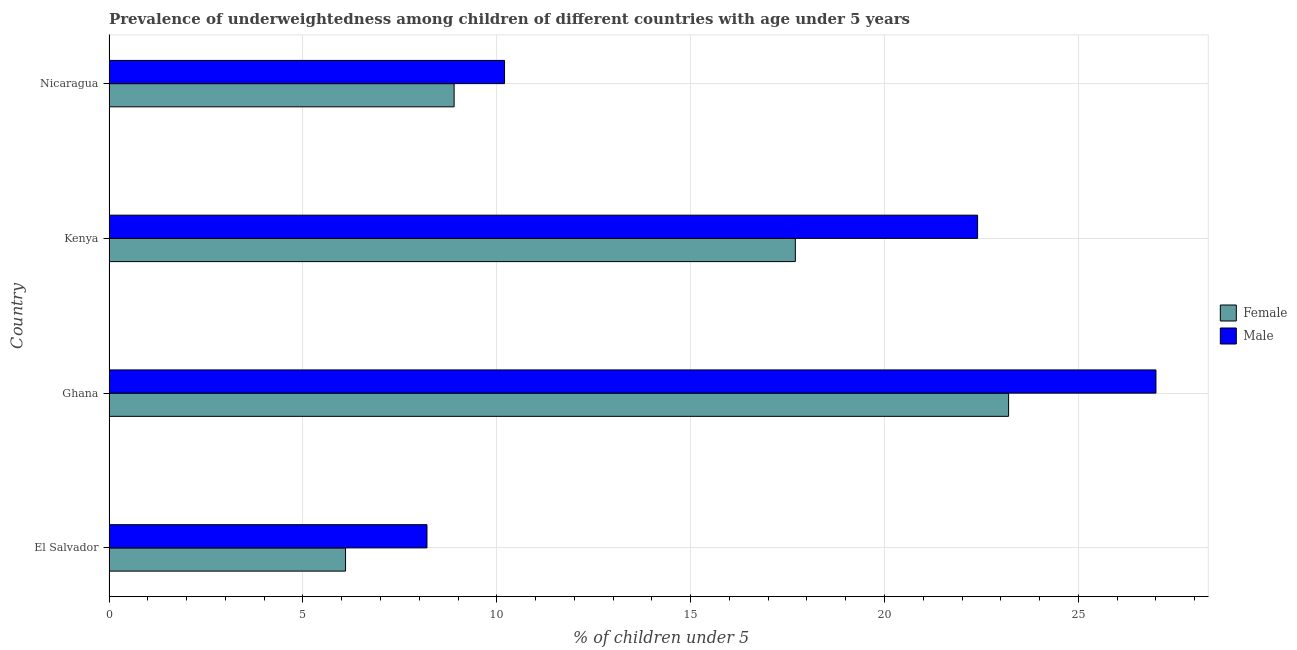How many different coloured bars are there?
Your response must be concise. 2. How many groups of bars are there?
Your answer should be very brief. 4. Are the number of bars per tick equal to the number of legend labels?
Offer a terse response. Yes. Are the number of bars on each tick of the Y-axis equal?
Your answer should be very brief. Yes. How many bars are there on the 3rd tick from the bottom?
Your answer should be very brief. 2. What is the label of the 4th group of bars from the top?
Keep it short and to the point. El Salvador. What is the percentage of underweighted male children in Kenya?
Provide a succinct answer. 22.4. Across all countries, what is the maximum percentage of underweighted female children?
Your answer should be compact. 23.2. Across all countries, what is the minimum percentage of underweighted male children?
Give a very brief answer. 8.2. In which country was the percentage of underweighted male children maximum?
Ensure brevity in your answer.  Ghana. In which country was the percentage of underweighted male children minimum?
Keep it short and to the point. El Salvador. What is the total percentage of underweighted female children in the graph?
Offer a very short reply. 55.9. What is the difference between the percentage of underweighted male children in Ghana and that in Nicaragua?
Give a very brief answer. 16.8. What is the difference between the percentage of underweighted female children in Ghana and the percentage of underweighted male children in Nicaragua?
Offer a terse response. 13. What is the average percentage of underweighted female children per country?
Offer a very short reply. 13.97. What is the difference between the percentage of underweighted female children and percentage of underweighted male children in El Salvador?
Your response must be concise. -2.1. What is the ratio of the percentage of underweighted male children in El Salvador to that in Nicaragua?
Provide a succinct answer. 0.8. Is the percentage of underweighted male children in Kenya less than that in Nicaragua?
Provide a short and direct response. No. What is the difference between the highest and the second highest percentage of underweighted female children?
Make the answer very short. 5.5. What is the difference between the highest and the lowest percentage of underweighted female children?
Make the answer very short. 17.1. What does the 1st bar from the top in Ghana represents?
Offer a terse response. Male. What does the 2nd bar from the bottom in Ghana represents?
Give a very brief answer. Male. Are all the bars in the graph horizontal?
Offer a very short reply. Yes. What is the difference between two consecutive major ticks on the X-axis?
Your answer should be compact. 5. Are the values on the major ticks of X-axis written in scientific E-notation?
Keep it short and to the point. No. Does the graph contain grids?
Keep it short and to the point. Yes. How many legend labels are there?
Provide a short and direct response. 2. What is the title of the graph?
Your answer should be very brief. Prevalence of underweightedness among children of different countries with age under 5 years. What is the label or title of the X-axis?
Make the answer very short.  % of children under 5. What is the label or title of the Y-axis?
Provide a succinct answer. Country. What is the  % of children under 5 in Female in El Salvador?
Your answer should be compact. 6.1. What is the  % of children under 5 in Male in El Salvador?
Your answer should be compact. 8.2. What is the  % of children under 5 in Female in Ghana?
Provide a short and direct response. 23.2. What is the  % of children under 5 of Male in Ghana?
Offer a terse response. 27. What is the  % of children under 5 of Female in Kenya?
Offer a very short reply. 17.7. What is the  % of children under 5 in Male in Kenya?
Your answer should be very brief. 22.4. What is the  % of children under 5 in Female in Nicaragua?
Offer a very short reply. 8.9. What is the  % of children under 5 in Male in Nicaragua?
Ensure brevity in your answer.  10.2. Across all countries, what is the maximum  % of children under 5 in Female?
Provide a short and direct response. 23.2. Across all countries, what is the minimum  % of children under 5 in Female?
Your response must be concise. 6.1. Across all countries, what is the minimum  % of children under 5 of Male?
Make the answer very short. 8.2. What is the total  % of children under 5 in Female in the graph?
Your answer should be compact. 55.9. What is the total  % of children under 5 in Male in the graph?
Ensure brevity in your answer.  67.8. What is the difference between the  % of children under 5 of Female in El Salvador and that in Ghana?
Offer a very short reply. -17.1. What is the difference between the  % of children under 5 in Male in El Salvador and that in Ghana?
Keep it short and to the point. -18.8. What is the difference between the  % of children under 5 of Female in El Salvador and that in Kenya?
Your answer should be very brief. -11.6. What is the difference between the  % of children under 5 of Male in El Salvador and that in Nicaragua?
Make the answer very short. -2. What is the difference between the  % of children under 5 in Female in Ghana and that in Nicaragua?
Your response must be concise. 14.3. What is the difference between the  % of children under 5 of Male in Ghana and that in Nicaragua?
Your answer should be compact. 16.8. What is the difference between the  % of children under 5 of Female in Kenya and that in Nicaragua?
Make the answer very short. 8.8. What is the difference between the  % of children under 5 of Female in El Salvador and the  % of children under 5 of Male in Ghana?
Offer a terse response. -20.9. What is the difference between the  % of children under 5 in Female in El Salvador and the  % of children under 5 in Male in Kenya?
Your answer should be very brief. -16.3. What is the difference between the  % of children under 5 of Female in El Salvador and the  % of children under 5 of Male in Nicaragua?
Ensure brevity in your answer.  -4.1. What is the difference between the  % of children under 5 of Female in Ghana and the  % of children under 5 of Male in Kenya?
Provide a short and direct response. 0.8. What is the average  % of children under 5 in Female per country?
Your answer should be compact. 13.97. What is the average  % of children under 5 of Male per country?
Make the answer very short. 16.95. What is the difference between the  % of children under 5 in Female and  % of children under 5 in Male in Ghana?
Offer a terse response. -3.8. What is the difference between the  % of children under 5 in Female and  % of children under 5 in Male in Kenya?
Offer a very short reply. -4.7. What is the difference between the  % of children under 5 of Female and  % of children under 5 of Male in Nicaragua?
Offer a very short reply. -1.3. What is the ratio of the  % of children under 5 in Female in El Salvador to that in Ghana?
Provide a succinct answer. 0.26. What is the ratio of the  % of children under 5 of Male in El Salvador to that in Ghana?
Make the answer very short. 0.3. What is the ratio of the  % of children under 5 of Female in El Salvador to that in Kenya?
Provide a succinct answer. 0.34. What is the ratio of the  % of children under 5 of Male in El Salvador to that in Kenya?
Ensure brevity in your answer.  0.37. What is the ratio of the  % of children under 5 of Female in El Salvador to that in Nicaragua?
Your answer should be compact. 0.69. What is the ratio of the  % of children under 5 in Male in El Salvador to that in Nicaragua?
Your answer should be compact. 0.8. What is the ratio of the  % of children under 5 of Female in Ghana to that in Kenya?
Give a very brief answer. 1.31. What is the ratio of the  % of children under 5 in Male in Ghana to that in Kenya?
Your answer should be very brief. 1.21. What is the ratio of the  % of children under 5 of Female in Ghana to that in Nicaragua?
Your response must be concise. 2.61. What is the ratio of the  % of children under 5 of Male in Ghana to that in Nicaragua?
Your answer should be compact. 2.65. What is the ratio of the  % of children under 5 in Female in Kenya to that in Nicaragua?
Provide a succinct answer. 1.99. What is the ratio of the  % of children under 5 in Male in Kenya to that in Nicaragua?
Provide a short and direct response. 2.2. What is the difference between the highest and the second highest  % of children under 5 of Male?
Your response must be concise. 4.6. What is the difference between the highest and the lowest  % of children under 5 of Female?
Your answer should be very brief. 17.1. What is the difference between the highest and the lowest  % of children under 5 of Male?
Your response must be concise. 18.8. 